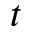Convert formula to latex. <formula><loc_0><loc_0><loc_500><loc_500>t</formula> 